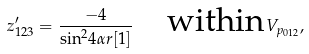<formula> <loc_0><loc_0><loc_500><loc_500>z ^ { \prime } _ { 1 2 3 } = \frac { - 4 } { { \sin } ^ { 2 } 4 \alpha r [ 1 ] } \quad \text {within} \, V _ { p _ { 0 1 2 } } ,</formula> 